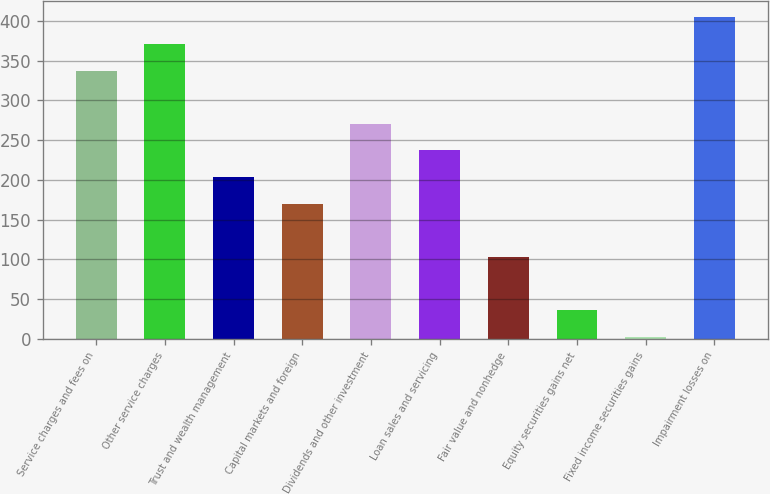Convert chart to OTSL. <chart><loc_0><loc_0><loc_500><loc_500><bar_chart><fcel>Service charges and fees on<fcel>Other service charges<fcel>Trust and wealth management<fcel>Capital markets and foreign<fcel>Dividends and other investment<fcel>Loan sales and servicing<fcel>Fair value and nonhedge<fcel>Equity securities gains net<fcel>Fixed income securities gains<fcel>Impairment losses on<nl><fcel>337.4<fcel>370.85<fcel>203.6<fcel>170.15<fcel>270.5<fcel>237.05<fcel>103.25<fcel>36.35<fcel>2.9<fcel>404.3<nl></chart> 